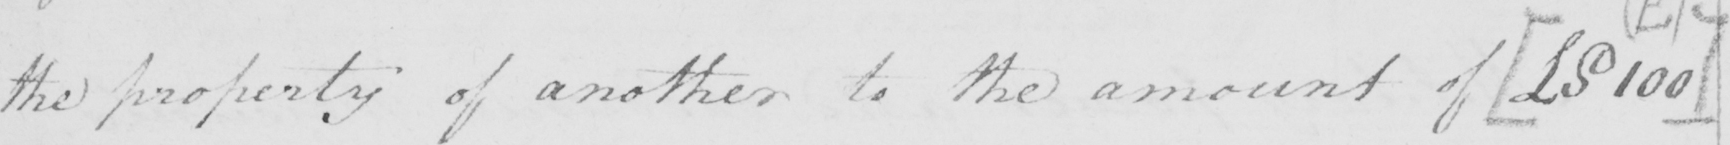Can you tell me what this handwritten text says? the property of another to the amount of  [ £S100 ] 